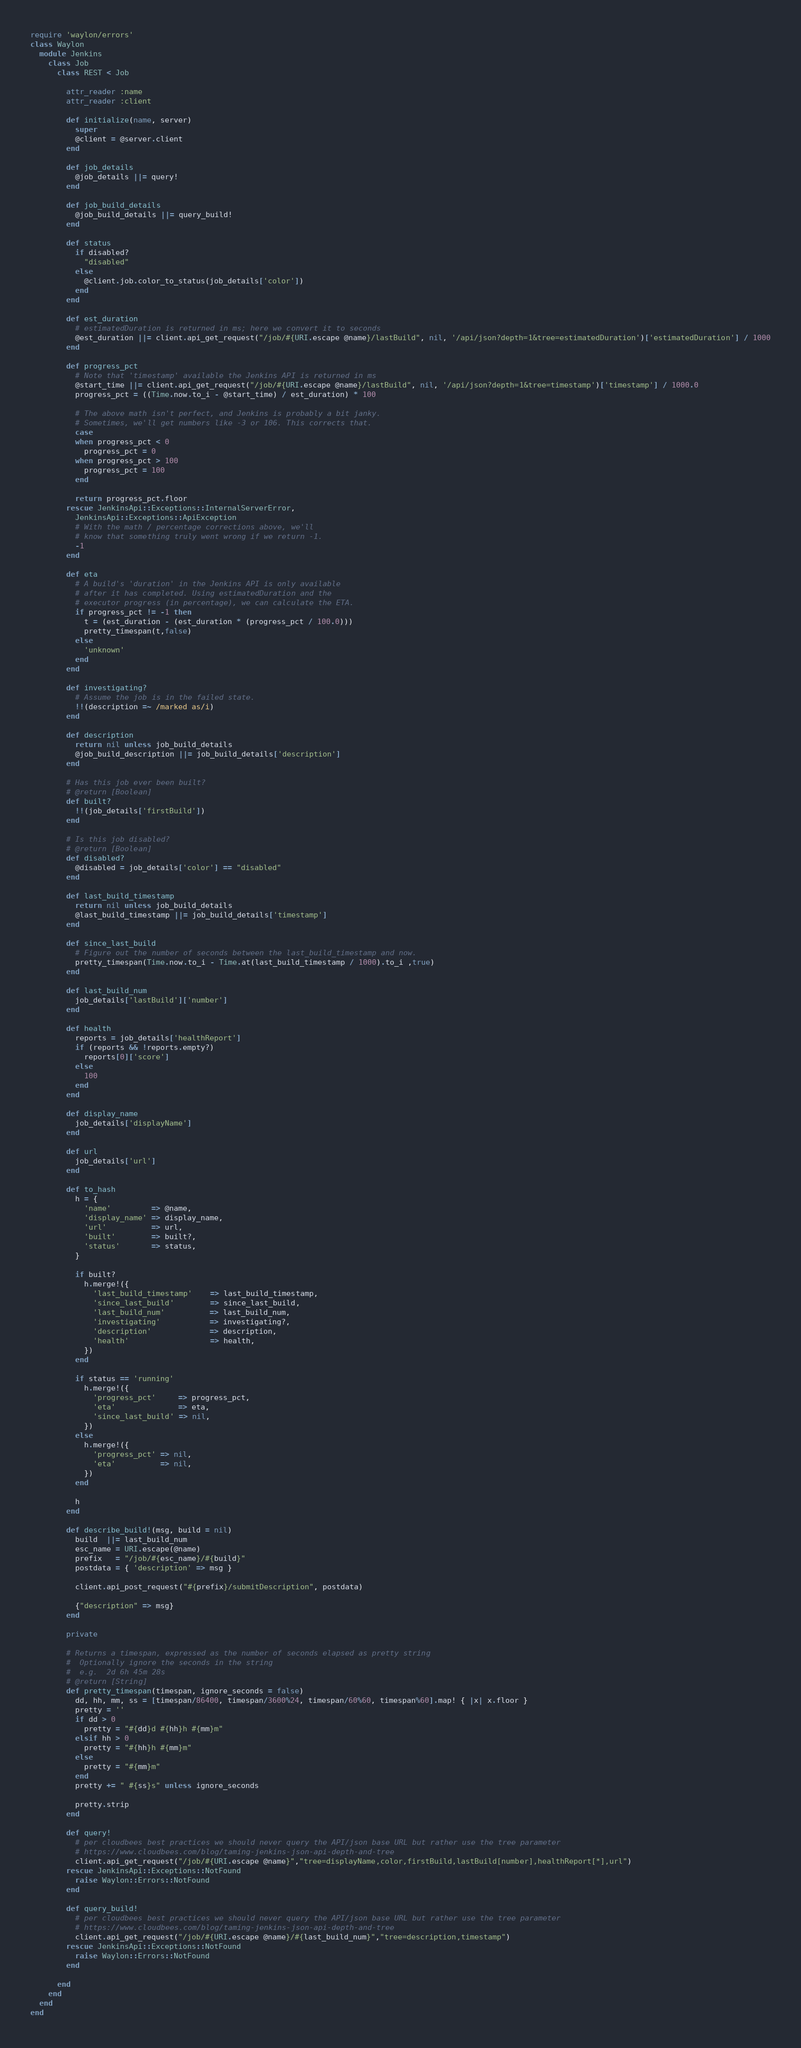Convert code to text. <code><loc_0><loc_0><loc_500><loc_500><_Ruby_>require 'waylon/errors'
class Waylon
  module Jenkins
    class Job
      class REST < Job

        attr_reader :name
        attr_reader :client

        def initialize(name, server)
          super
          @client = @server.client
        end

        def job_details
          @job_details ||= query!
        end

        def job_build_details
          @job_build_details ||= query_build!
        end

        def status
          if disabled?
            "disabled"
          else
            @client.job.color_to_status(job_details['color'])
          end
        end

        def est_duration
          # estimatedDuration is returned in ms; here we convert it to seconds
          @est_duration ||= client.api_get_request("/job/#{URI.escape @name}/lastBuild", nil, '/api/json?depth=1&tree=estimatedDuration')['estimatedDuration'] / 1000
        end

        def progress_pct
          # Note that 'timestamp' available the Jenkins API is returned in ms
          @start_time ||= client.api_get_request("/job/#{URI.escape @name}/lastBuild", nil, '/api/json?depth=1&tree=timestamp')['timestamp'] / 1000.0
          progress_pct = ((Time.now.to_i - @start_time) / est_duration) * 100

          # The above math isn't perfect, and Jenkins is probably a bit janky.
          # Sometimes, we'll get numbers like -3 or 106. This corrects that.
          case
          when progress_pct < 0
            progress_pct = 0
          when progress_pct > 100
            progress_pct = 100
          end

          return progress_pct.floor
        rescue JenkinsApi::Exceptions::InternalServerError,
          JenkinsApi::Exceptions::ApiException
          # With the math / percentage corrections above, we'll
          # know that something truly went wrong if we return -1.
          -1
        end

        def eta
          # A build's 'duration' in the Jenkins API is only available
          # after it has completed. Using estimatedDuration and the
          # executor progress (in percentage), we can calculate the ETA.
          if progress_pct != -1 then
            t = (est_duration - (est_duration * (progress_pct / 100.0)))
            pretty_timespan(t,false)
          else
            'unknown'
          end
        end

        def investigating?
          # Assume the job is in the failed state.
          !!(description =~ /marked as/i)
        end

        def description
          return nil unless job_build_details
          @job_build_description ||= job_build_details['description']
        end

        # Has this job ever been built?
        # @return [Boolean]
        def built?
          !!(job_details['firstBuild'])
        end

        # Is this job disabled?
        # @return [Boolean]
        def disabled?
          @disabled = job_details['color'] == "disabled"
        end

        def last_build_timestamp
          return nil unless job_build_details
          @last_build_timestamp ||= job_build_details['timestamp']
        end

        def since_last_build
          # Figure out the number of seconds between the last_build_timestamp and now.
          pretty_timespan(Time.now.to_i - Time.at(last_build_timestamp / 1000).to_i ,true)
        end

        def last_build_num
          job_details['lastBuild']['number']
        end

        def health
          reports = job_details['healthReport']
          if (reports && !reports.empty?)
            reports[0]['score']
          else
            100
          end
        end

        def display_name
          job_details['displayName']
        end

        def url
          job_details['url']
        end

        def to_hash
          h = {
            'name'         => @name,
            'display_name' => display_name,
            'url'          => url,
            'built'        => built?,
            'status'       => status,
          }

          if built?
            h.merge!({
              'last_build_timestamp'    => last_build_timestamp,
              'since_last_build'        => since_last_build,
              'last_build_num'          => last_build_num,
              'investigating'           => investigating?,
              'description'             => description,
              'health'                  => health,
            })
          end

          if status == 'running'
            h.merge!({
              'progress_pct'     => progress_pct,
              'eta'              => eta,
              'since_last_build' => nil,
            })
          else
            h.merge!({
              'progress_pct' => nil,
              'eta'          => nil,
            })
          end

          h
        end

        def describe_build!(msg, build = nil)
          build  ||= last_build_num
          esc_name = URI.escape(@name)
          prefix   = "/job/#{esc_name}/#{build}"
          postdata = { 'description' => msg }

          client.api_post_request("#{prefix}/submitDescription", postdata)

          {"description" => msg}
        end

        private

        # Returns a timespan, expressed as the number of seconds elapsed as pretty string
        #  Optionally ignore the seconds in the string
        #  e.g.  2d 6h 45m 28s
        # @return [String]
        def pretty_timespan(timespan, ignore_seconds = false)
          dd, hh, mm, ss = [timespan/86400, timespan/3600%24, timespan/60%60, timespan%60].map! { |x| x.floor }
          pretty = ''
          if dd > 0
            pretty = "#{dd}d #{hh}h #{mm}m"
          elsif hh > 0
            pretty = "#{hh}h #{mm}m"
          else
            pretty = "#{mm}m"
          end
          pretty += " #{ss}s" unless ignore_seconds

          pretty.strip
        end

        def query!
          # per cloudbees best practices we should never query the API/json base URL but rather use the tree parameter
          # https://www.cloudbees.com/blog/taming-jenkins-json-api-depth-and-tree
          client.api_get_request("/job/#{URI.escape @name}","tree=displayName,color,firstBuild,lastBuild[number],healthReport[*],url")
        rescue JenkinsApi::Exceptions::NotFound
          raise Waylon::Errors::NotFound
        end

        def query_build!
          # per cloudbees best practices we should never query the API/json base URL but rather use the tree parameter
          # https://www.cloudbees.com/blog/taming-jenkins-json-api-depth-and-tree
          client.api_get_request("/job/#{URI.escape @name}/#{last_build_num}","tree=description,timestamp")
        rescue JenkinsApi::Exceptions::NotFound
          raise Waylon::Errors::NotFound
        end

      end
    end
  end
end
</code> 